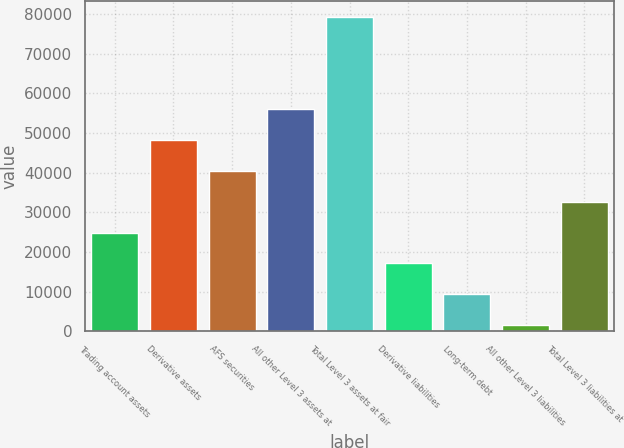Convert chart. <chart><loc_0><loc_0><loc_500><loc_500><bar_chart><fcel>Trading account assets<fcel>Derivative assets<fcel>AFS securities<fcel>All other Level 3 assets at<fcel>Total Level 3 assets at fair<fcel>Derivative liabilities<fcel>Long-term debt<fcel>All other Level 3 liabilities<fcel>Total Level 3 liabilities at<nl><fcel>24895.1<fcel>48249.2<fcel>40464.5<fcel>56033.9<fcel>79388<fcel>17110.4<fcel>9325.7<fcel>1541<fcel>32679.8<nl></chart> 